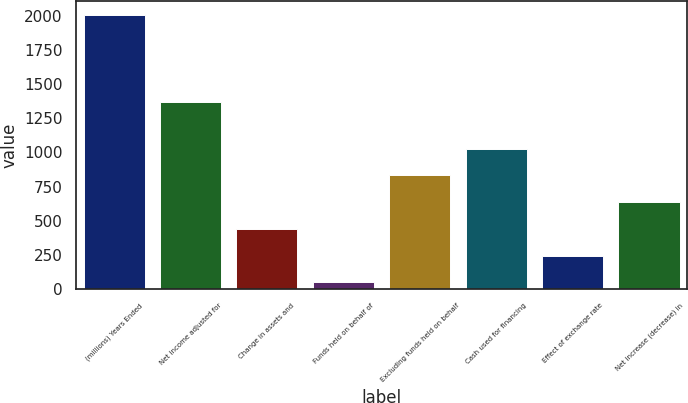Convert chart to OTSL. <chart><loc_0><loc_0><loc_500><loc_500><bar_chart><fcel>(millions) Years Ended<fcel>Net income adjusted for<fcel>Change in assets and<fcel>Funds held on behalf of<fcel>Excluding funds held on behalf<fcel>Cash used for financing<fcel>Effect of exchange rate<fcel>Net increase (decrease) in<nl><fcel>2007<fcel>1366<fcel>441.4<fcel>50<fcel>832.8<fcel>1028.5<fcel>245.7<fcel>637.1<nl></chart> 